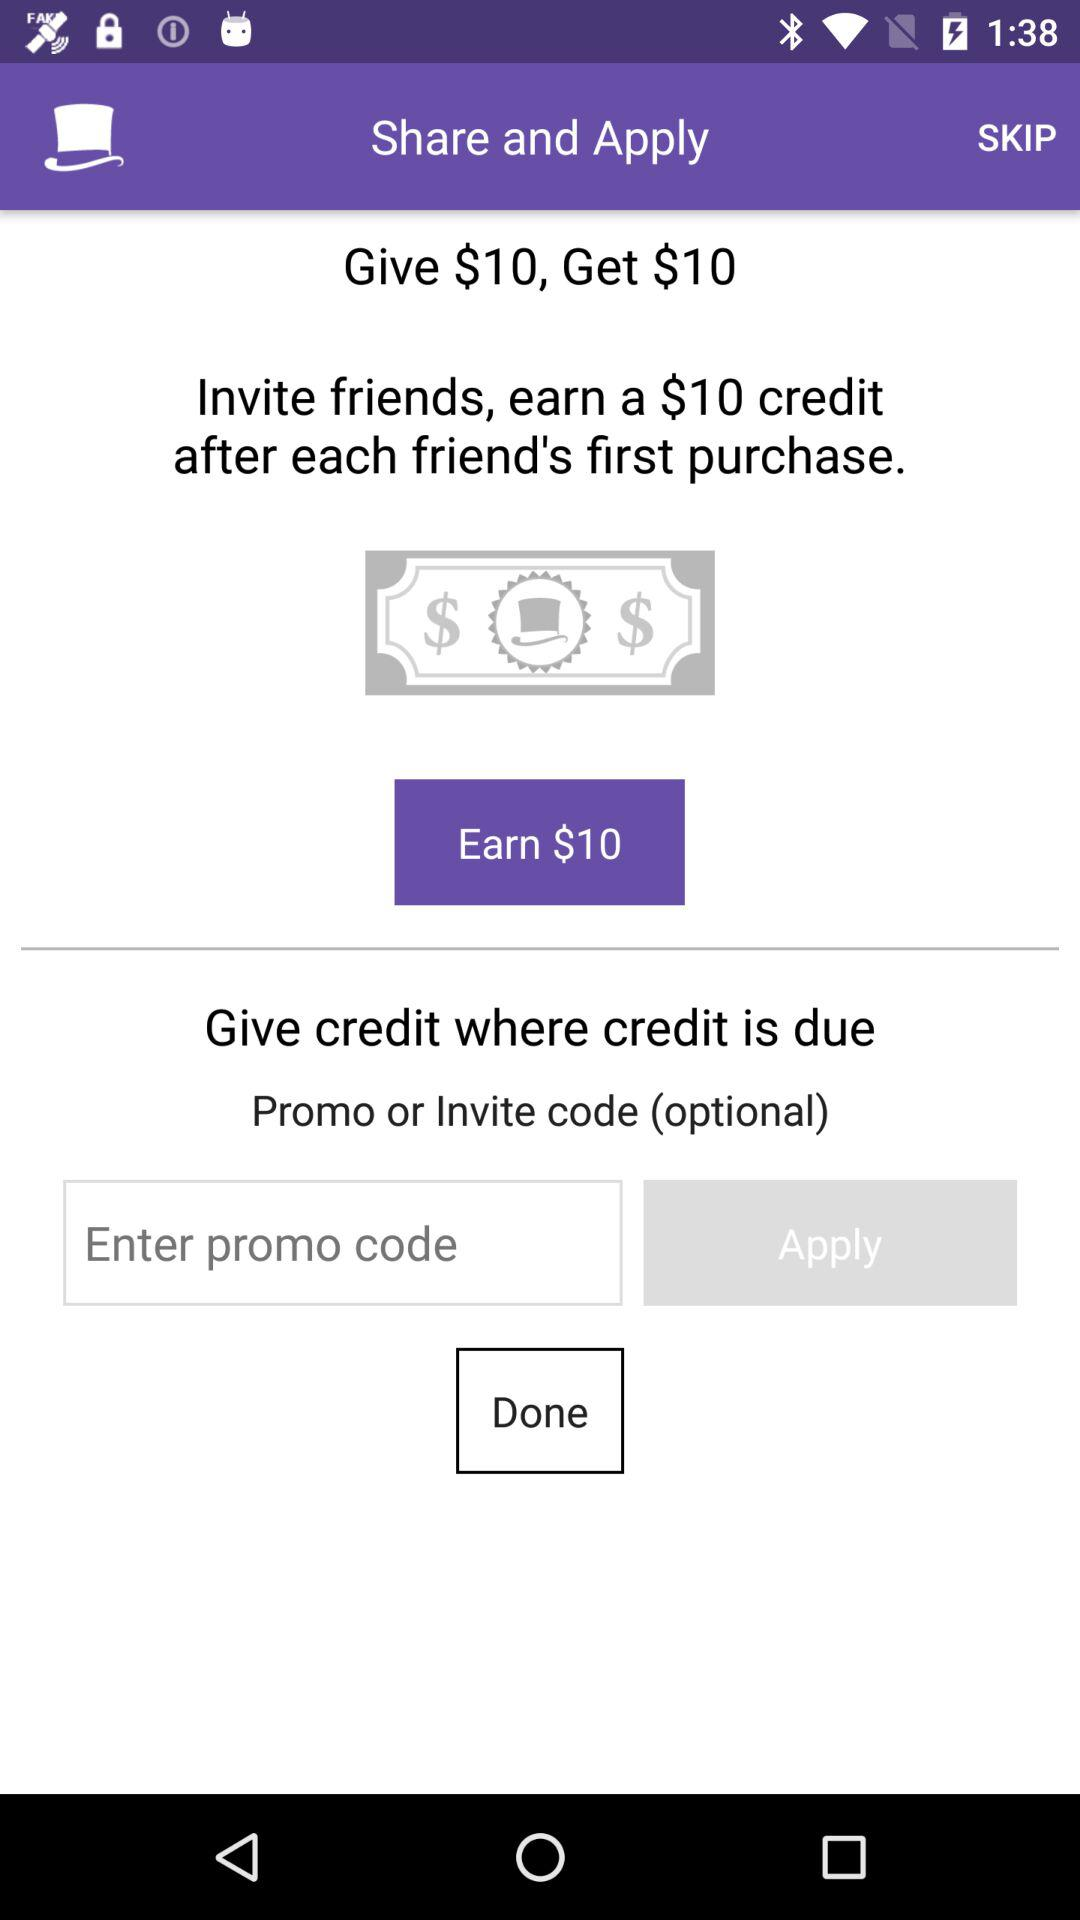How many more dollars can I earn by inviting friends than by entering a promo code?
Answer the question using a single word or phrase. 10 